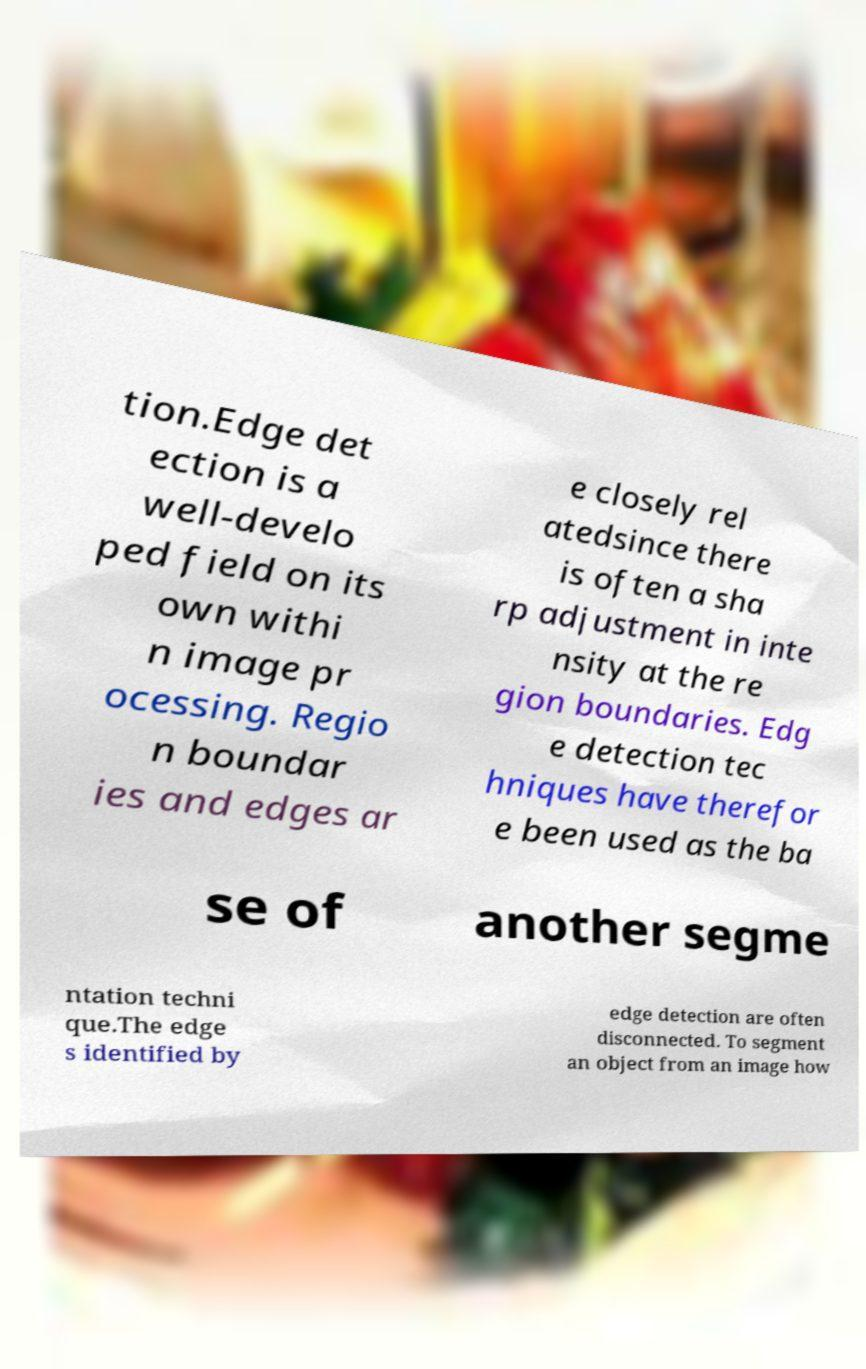Could you extract and type out the text from this image? tion.Edge det ection is a well-develo ped field on its own withi n image pr ocessing. Regio n boundar ies and edges ar e closely rel atedsince there is often a sha rp adjustment in inte nsity at the re gion boundaries. Edg e detection tec hniques have therefor e been used as the ba se of another segme ntation techni que.The edge s identified by edge detection are often disconnected. To segment an object from an image how 